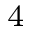<formula> <loc_0><loc_0><loc_500><loc_500>^ { 4 }</formula> 